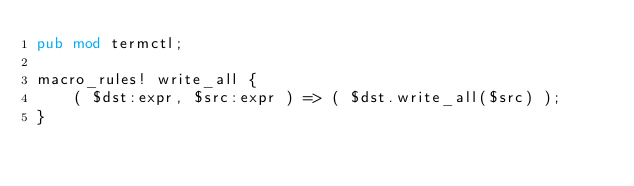<code> <loc_0><loc_0><loc_500><loc_500><_Rust_>pub mod termctl;

macro_rules! write_all {
    ( $dst:expr, $src:expr ) => ( $dst.write_all($src) );
}
</code> 